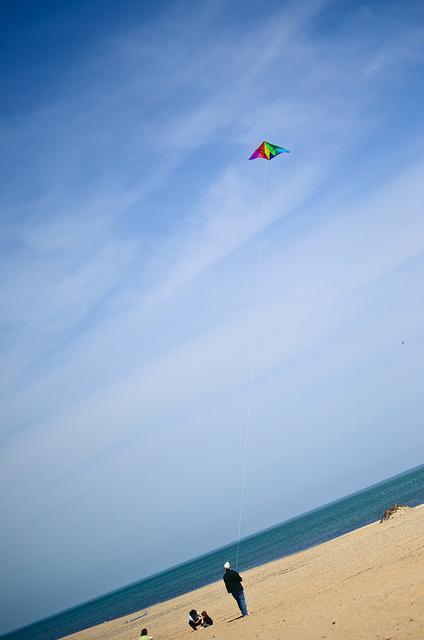How many water ski board have yellow lights shedding on them?
Give a very brief answer. 0. 